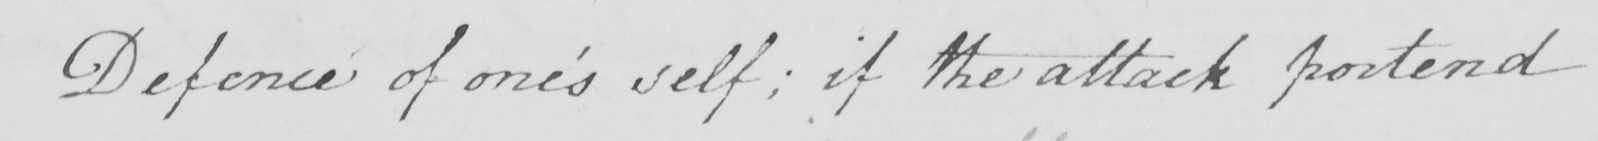What does this handwritten line say? Defence of one ' s self ; if the attack portend 